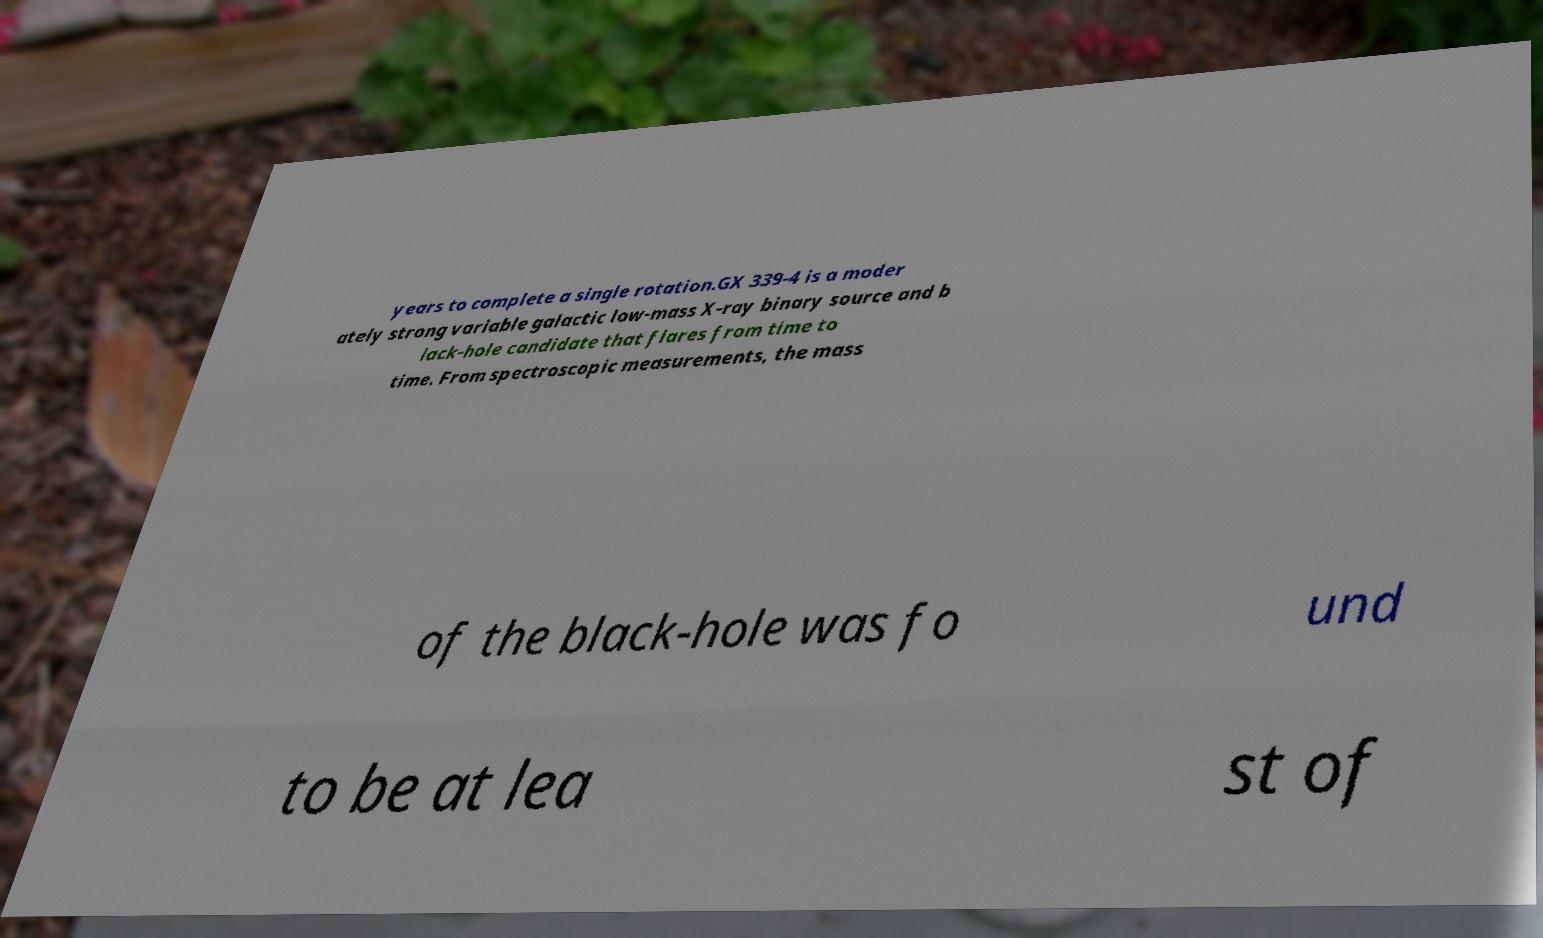Could you assist in decoding the text presented in this image and type it out clearly? years to complete a single rotation.GX 339-4 is a moder ately strong variable galactic low-mass X-ray binary source and b lack-hole candidate that flares from time to time. From spectroscopic measurements, the mass of the black-hole was fo und to be at lea st of 